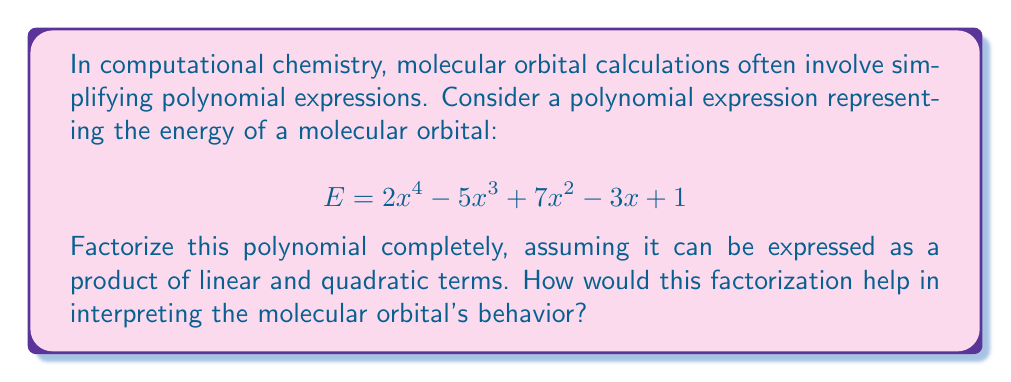Help me with this question. To factorize this polynomial, we'll follow these steps:

1) First, let's check for any common factors. There are none in this case.

2) Next, we'll use the rational root theorem to find potential roots. The possible rational roots are the factors of the constant term (1): ±1.

3) Let's test these potential roots:
   For x = 1: $2(1)^4 - 5(1)^3 + 7(1)^2 - 3(1) + 1 = 2 - 5 + 7 - 3 + 1 = 2$
   For x = -1: $2(-1)^4 - 5(-1)^3 + 7(-1)^2 - 3(-1) + 1 = 2 + 5 + 7 + 3 + 1 = 18$

   Neither of these are roots.

4) Since there are no rational roots, the polynomial must have two quadratic factors.

5) We can use the AC-method or grouping to find these factors:

   $2x^4 - 5x^3 + 7x^2 - 3x + 1$
   $= (2x^2 + ax + b)(x^2 + cx + d)$

   Expanding this:
   $2x^4 + (2c+a)x^3 + (2d+ac+b)x^2 + (ad+bc)x + bd$

   Comparing coefficients:
   $2c+a = -5$
   $2d+ac+b = 7$
   $ad+bc = -3$
   $bd = 1$

6) After some trial and error or using a computer algebra system, we find:
   $a = -1, b = 2, c = -2, d = \frac{1}{2}$

7) Therefore, the factorization is:
   $$(2x^2 - x + 2)(x^2 - 2x + \frac{1}{2})$$

This factorization helps in interpreting the molecular orbital's behavior by breaking down the complex energy expression into simpler components. Each quadratic factor represents a distinct contribution to the overall energy. The roots of these quadratic factors (if real) would indicate energy levels where the orbital's behavior changes significantly. The absence of linear factors suggests that there are no simple, single-electron interactions dominating the orbital's behavior.
Answer: $E = (2x^2 - x + 2)(x^2 - 2x + \frac{1}{2})$ 